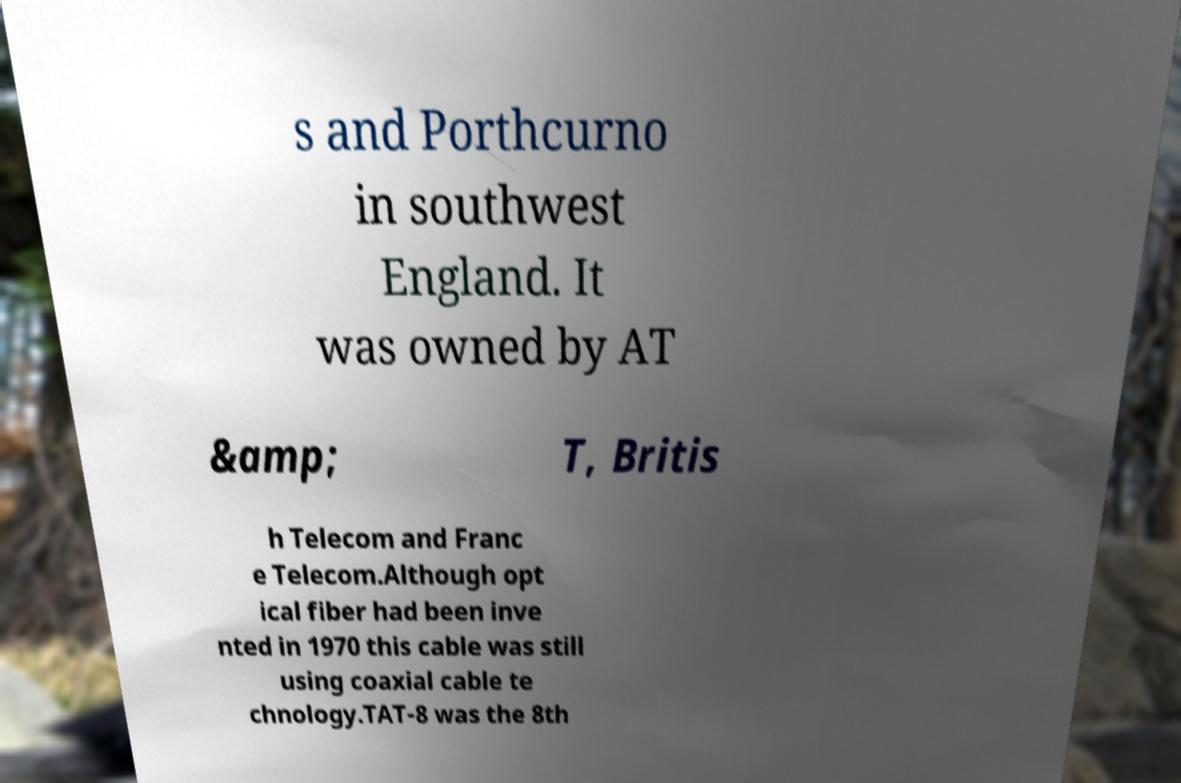What messages or text are displayed in this image? I need them in a readable, typed format. s and Porthcurno in southwest England. It was owned by AT &amp; T, Britis h Telecom and Franc e Telecom.Although opt ical fiber had been inve nted in 1970 this cable was still using coaxial cable te chnology.TAT-8 was the 8th 